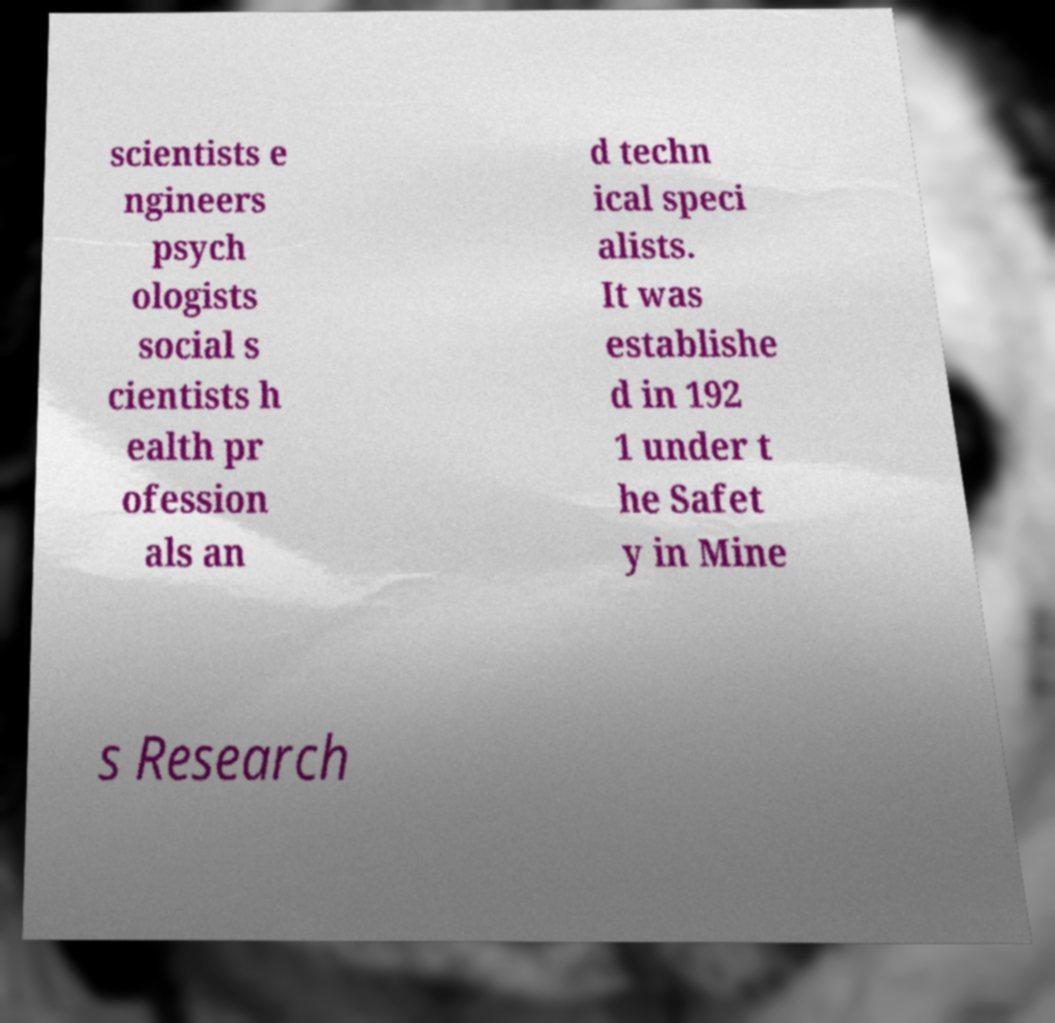Can you accurately transcribe the text from the provided image for me? scientists e ngineers psych ologists social s cientists h ealth pr ofession als an d techn ical speci alists. It was establishe d in 192 1 under t he Safet y in Mine s Research 